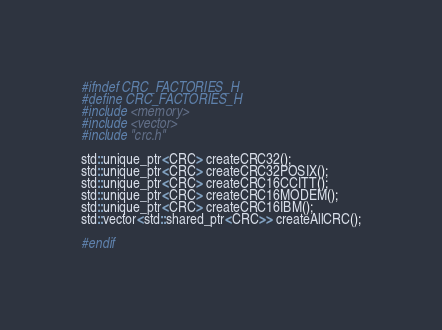Convert code to text. <code><loc_0><loc_0><loc_500><loc_500><_C_>#ifndef CRC_FACTORIES_H
#define CRC_FACTORIES_H
#include <memory>
#include <vector>
#include "crc.h"

std::unique_ptr<CRC> createCRC32();
std::unique_ptr<CRC> createCRC32POSIX();
std::unique_ptr<CRC> createCRC16CCITT();
std::unique_ptr<CRC> createCRC16MODEM();
std::unique_ptr<CRC> createCRC16IBM();
std::vector<std::shared_ptr<CRC>> createAllCRC();

#endif
</code> 